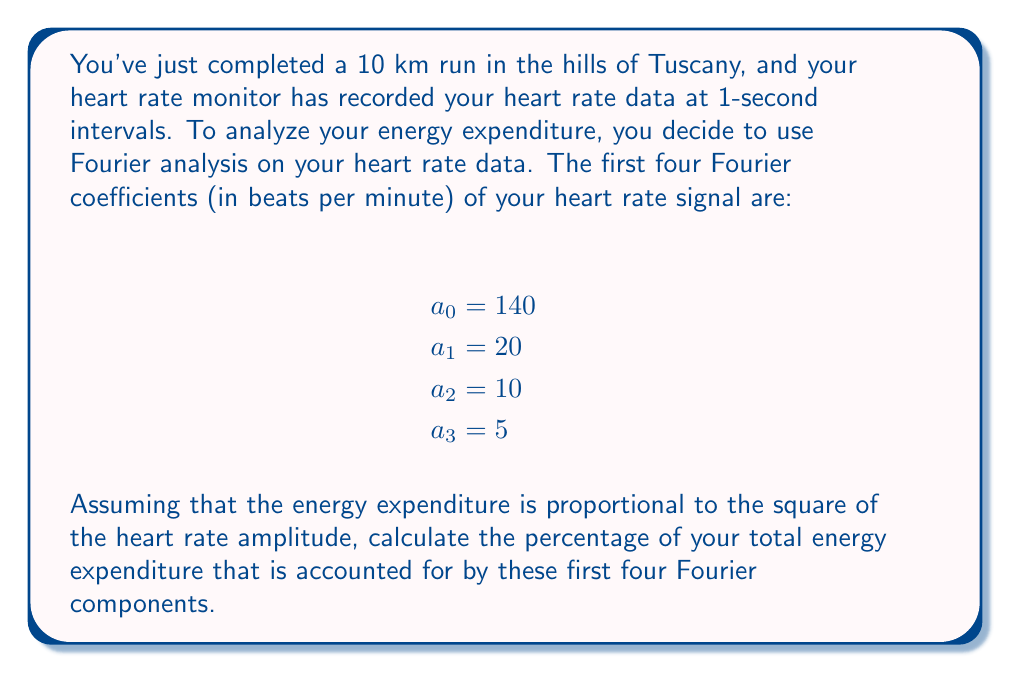Help me with this question. To solve this problem, we'll follow these steps:

1) In Fourier analysis, the total energy of a signal is proportional to the sum of the squares of its Fourier coefficients, according to Parseval's theorem.

2) The energy associated with each Fourier component is proportional to the square of its amplitude:

   $E_n \propto a_n^2$

3) Let's calculate the energy for each component:

   $E_0 \propto 140^2 = 19600$
   $E_1 \propto 20^2 = 400$
   $E_2 \propto 10^2 = 100$
   $E_3 \propto 5^2 = 25$

4) The total energy from these four components is the sum:

   $E_{total} = 19600 + 400 + 100 + 25 = 20125$

5) However, this is not the total energy of the entire signal. The complete signal would include all Fourier components, potentially an infinite number of them.

6) The percentage of energy accounted for by these four components is:

   $\text{Percentage} = \frac{E_{total}}{E_{complete}} \times 100\%$

   Where $E_{complete}$ is the energy of the complete signal, which we don't know.

7) However, we can say that this percentage is less than or equal to 100%, as these four components cannot account for more than the total energy of the signal.

8) Therefore, the percentage of total energy expenditure accounted for by these four Fourier components is:

   $\text{Percentage} \leq \frac{20125}{20125} \times 100\% = 100\%$

The actual percentage is likely less than 100%, as there are probably additional Fourier components not included in this analysis.
Answer: The first four Fourier components account for up to 100% of the total energy expenditure, but the actual percentage is likely less and cannot be determined precisely without information about the higher-order Fourier coefficients. 